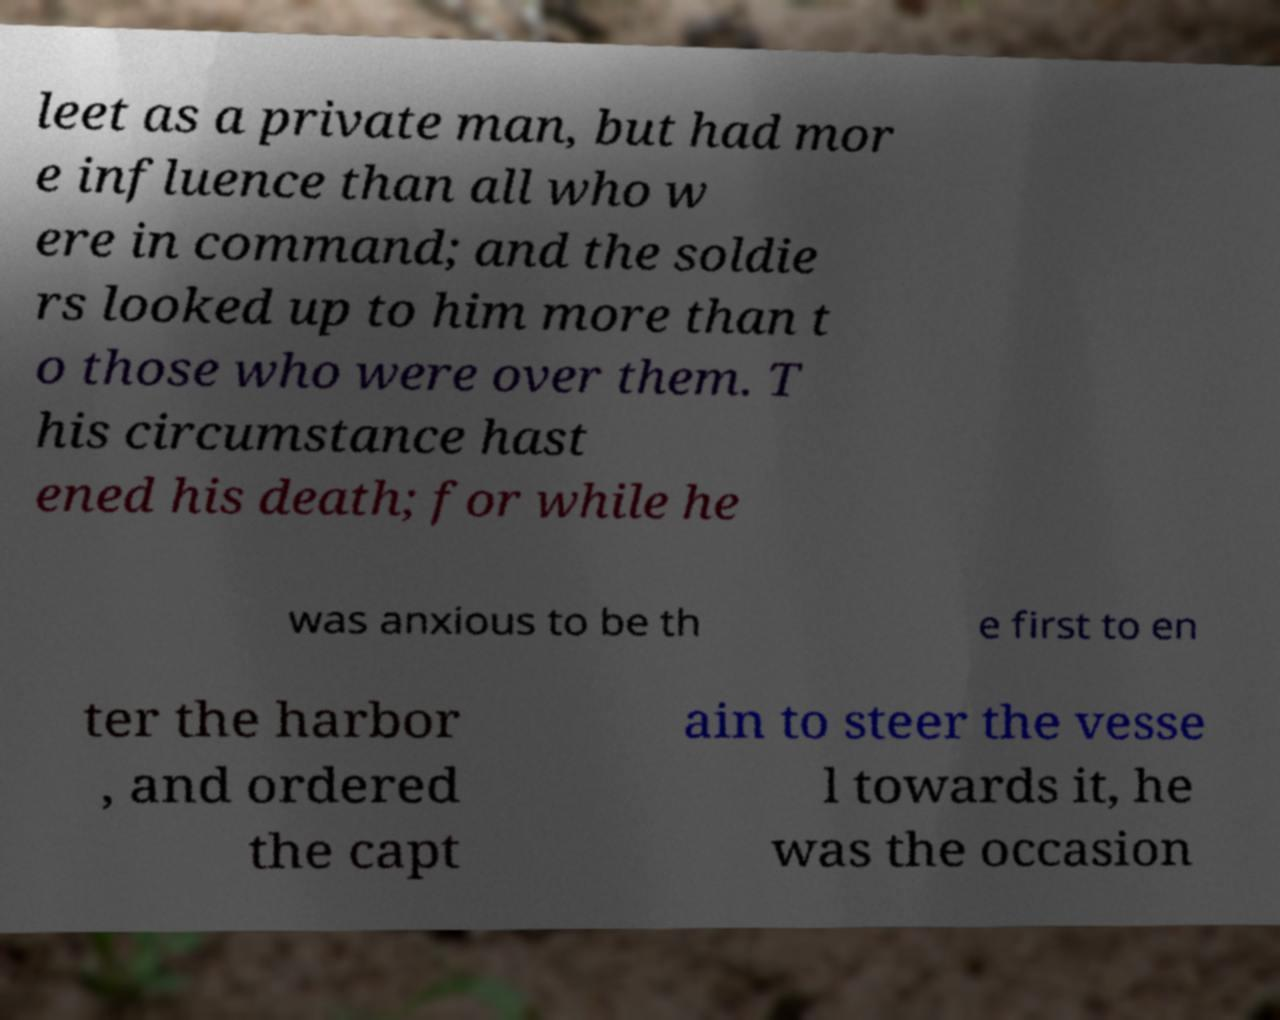I need the written content from this picture converted into text. Can you do that? leet as a private man, but had mor e influence than all who w ere in command; and the soldie rs looked up to him more than t o those who were over them. T his circumstance hast ened his death; for while he was anxious to be th e first to en ter the harbor , and ordered the capt ain to steer the vesse l towards it, he was the occasion 